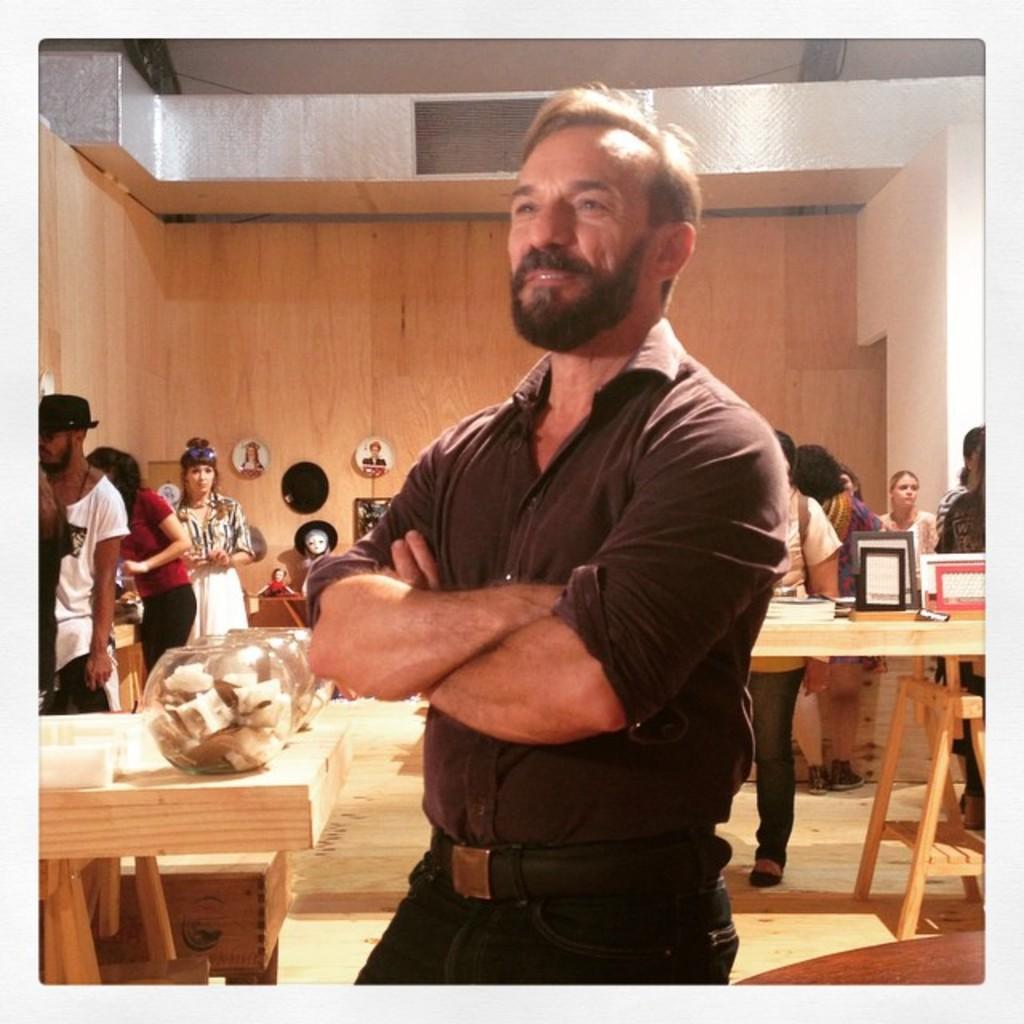Please provide a concise description of this image. In the picture we can see a man standing on the floor, he is with a black color shirt, belt and trouser and on the other sides we can see some tables and some things are placed on it and some people are working on it and in the background we can see a wooden wall. 